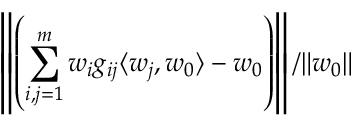<formula> <loc_0><loc_0><loc_500><loc_500>\left \| \left ( \sum _ { i , j = 1 } ^ { m } w _ { i } g _ { i j } \langle w _ { j } , w _ { 0 } \rangle - w _ { 0 } \right ) \right \| / \| w _ { 0 } \|</formula> 